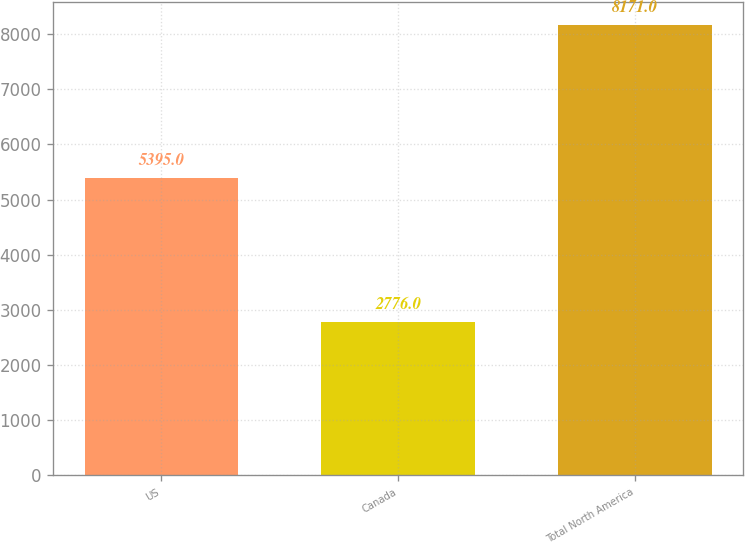Convert chart to OTSL. <chart><loc_0><loc_0><loc_500><loc_500><bar_chart><fcel>US<fcel>Canada<fcel>Total North America<nl><fcel>5395<fcel>2776<fcel>8171<nl></chart> 